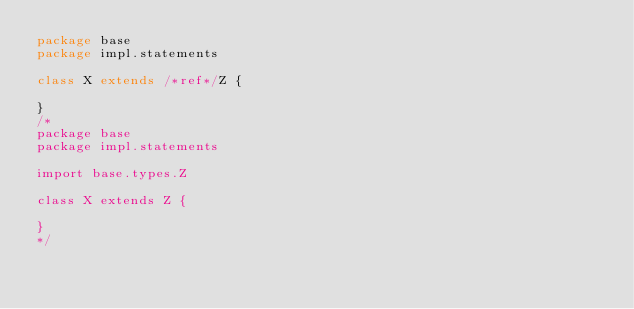Convert code to text. <code><loc_0><loc_0><loc_500><loc_500><_Scala_>package base
package impl.statements

class X extends /*ref*/Z {

}
/*
package base
package impl.statements

import base.types.Z

class X extends Z {

}
*/</code> 